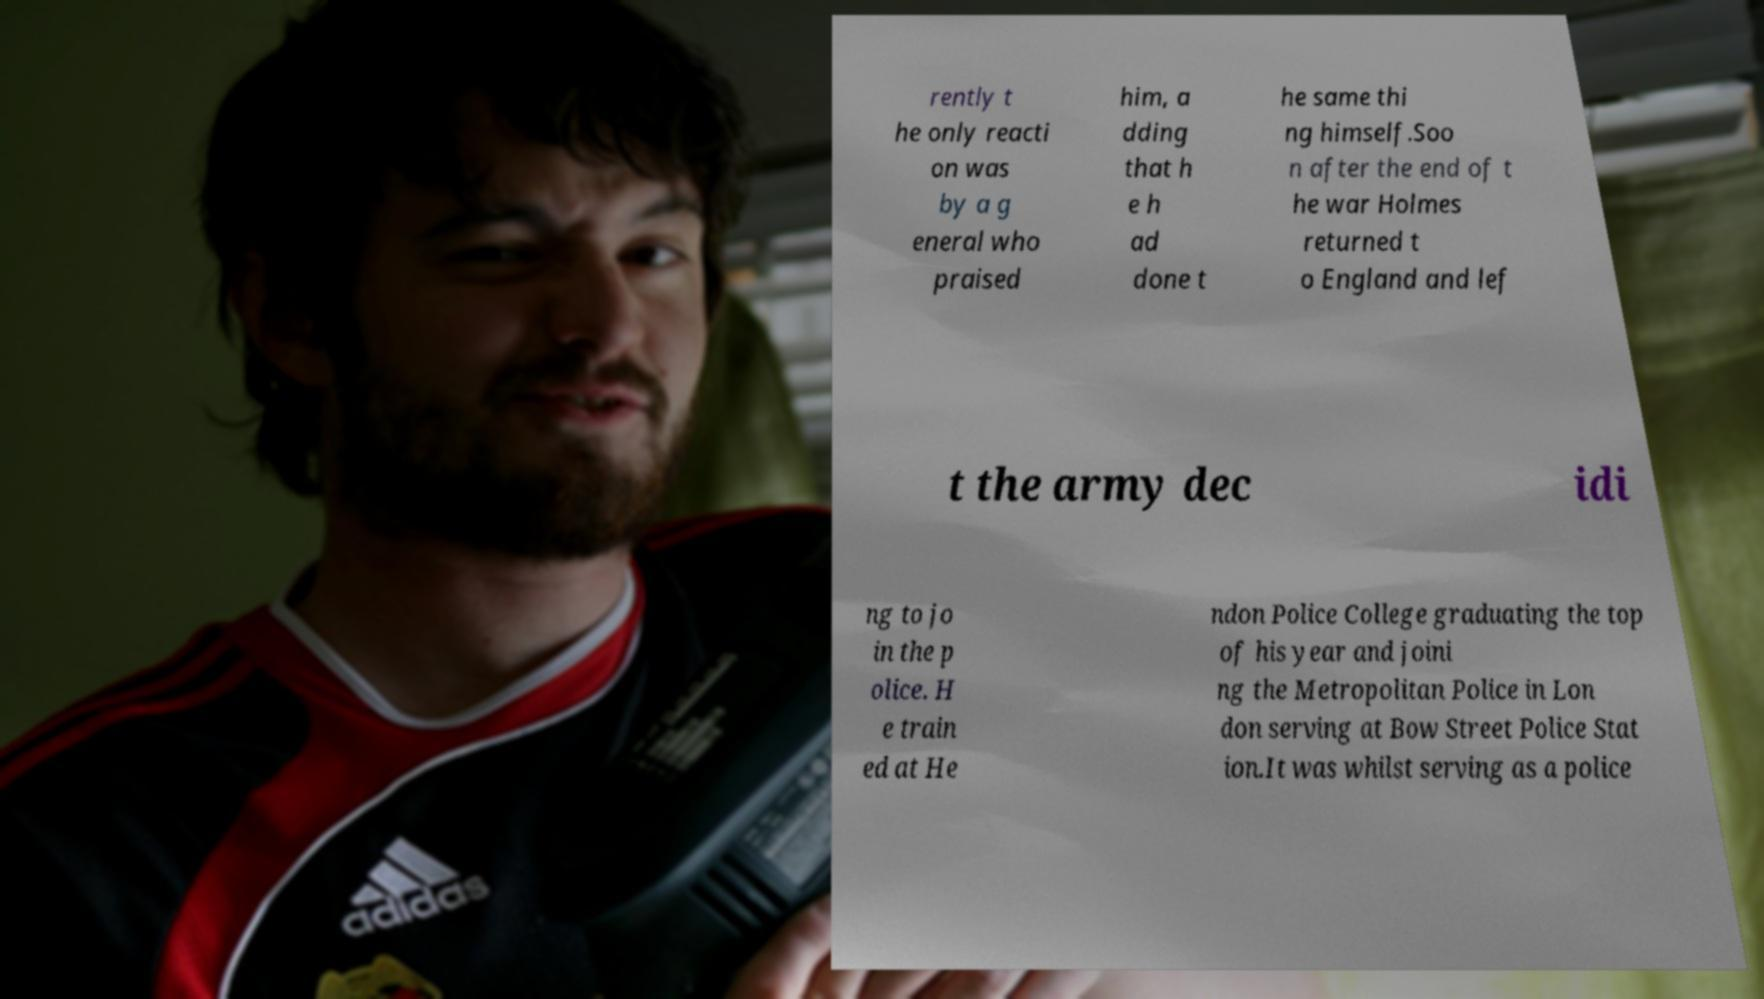For documentation purposes, I need the text within this image transcribed. Could you provide that? rently t he only reacti on was by a g eneral who praised him, a dding that h e h ad done t he same thi ng himself.Soo n after the end of t he war Holmes returned t o England and lef t the army dec idi ng to jo in the p olice. H e train ed at He ndon Police College graduating the top of his year and joini ng the Metropolitan Police in Lon don serving at Bow Street Police Stat ion.It was whilst serving as a police 